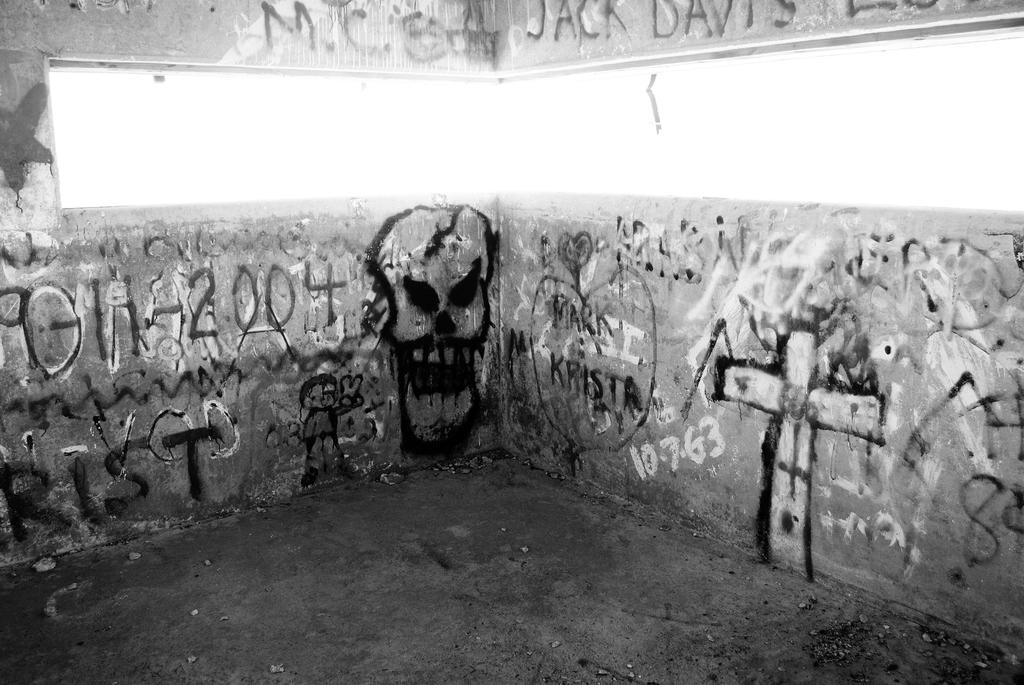What type of structure can be seen in the image? There is a wall in the image. Is there any opening in the wall? Yes, there is a window in the image. What is written on the wall or window? There is writing on the wall or window. What type of artwork is present in the image? There is a painting on the wall. What is the color scheme of the image? The image is in black and white. What type of camera can be seen in the image? There is no camera present in the image. What is the downtown area like in the image? The image does not depict a downtown area; it only shows a wall, window, writing, painting, and a black and white color scheme. 